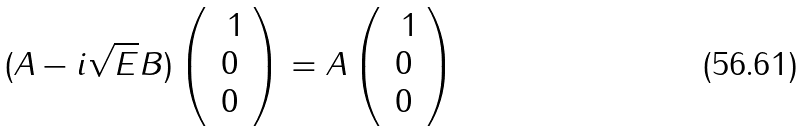<formula> <loc_0><loc_0><loc_500><loc_500>( A - i \sqrt { E } B ) \left ( \begin{array} { c } \ 1 \\ 0 \\ 0 \end{array} \right ) = A \left ( \begin{array} { c } \ 1 \\ 0 \\ 0 \end{array} \right )</formula> 